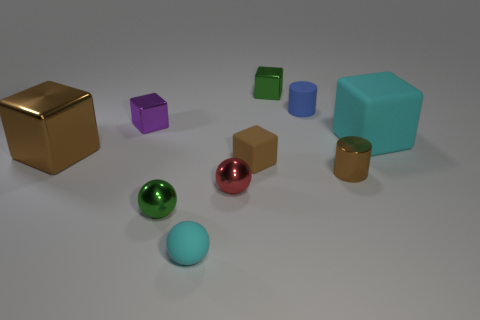There is another thing that is the same color as the big rubber object; what size is it?
Offer a very short reply. Small. What material is the other thing that is the same color as the big rubber thing?
Your answer should be very brief. Rubber. There is another green thing that is the same shape as the big metal object; what material is it?
Keep it short and to the point. Metal. Are there any blocks in front of the brown metal cylinder?
Provide a succinct answer. No. Is the material of the cyan object behind the tiny shiny cylinder the same as the small red ball?
Provide a short and direct response. No. Is there another rubber block that has the same color as the small rubber cube?
Offer a very short reply. No. What is the shape of the small blue rubber object?
Make the answer very short. Cylinder. What color is the small metal sphere that is in front of the metallic ball that is to the right of the green sphere?
Ensure brevity in your answer.  Green. There is a green object to the left of the small brown matte cube; what is its size?
Your response must be concise. Small. Are there any big cyan objects that have the same material as the small blue object?
Your response must be concise. Yes. 